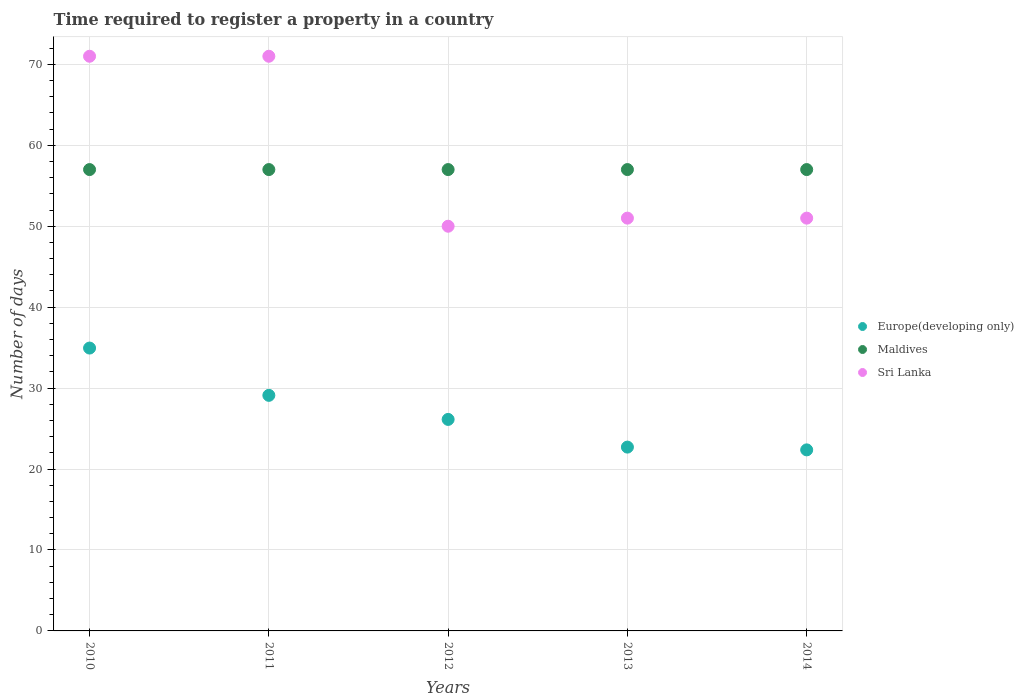What is the number of days required to register a property in Europe(developing only) in 2013?
Offer a very short reply. 22.71. Across all years, what is the maximum number of days required to register a property in Sri Lanka?
Keep it short and to the point. 71. Across all years, what is the minimum number of days required to register a property in Sri Lanka?
Provide a short and direct response. 50. In which year was the number of days required to register a property in Maldives minimum?
Offer a very short reply. 2010. What is the total number of days required to register a property in Sri Lanka in the graph?
Provide a short and direct response. 294. What is the difference between the number of days required to register a property in Maldives in 2010 and that in 2013?
Give a very brief answer. 0. What is the difference between the number of days required to register a property in Europe(developing only) in 2014 and the number of days required to register a property in Sri Lanka in 2012?
Give a very brief answer. -27.63. What is the average number of days required to register a property in Sri Lanka per year?
Ensure brevity in your answer.  58.8. In the year 2011, what is the difference between the number of days required to register a property in Sri Lanka and number of days required to register a property in Europe(developing only)?
Provide a succinct answer. 41.89. What is the ratio of the number of days required to register a property in Maldives in 2010 to that in 2013?
Ensure brevity in your answer.  1. Is the number of days required to register a property in Sri Lanka in 2012 less than that in 2013?
Give a very brief answer. Yes. Is the difference between the number of days required to register a property in Sri Lanka in 2010 and 2011 greater than the difference between the number of days required to register a property in Europe(developing only) in 2010 and 2011?
Provide a short and direct response. No. What is the difference between the highest and the second highest number of days required to register a property in Sri Lanka?
Keep it short and to the point. 0. What is the difference between the highest and the lowest number of days required to register a property in Sri Lanka?
Offer a terse response. 21. In how many years, is the number of days required to register a property in Europe(developing only) greater than the average number of days required to register a property in Europe(developing only) taken over all years?
Give a very brief answer. 2. Is it the case that in every year, the sum of the number of days required to register a property in Europe(developing only) and number of days required to register a property in Maldives  is greater than the number of days required to register a property in Sri Lanka?
Your answer should be compact. Yes. Does the number of days required to register a property in Maldives monotonically increase over the years?
Offer a very short reply. No. Is the number of days required to register a property in Maldives strictly less than the number of days required to register a property in Sri Lanka over the years?
Offer a very short reply. No. How many dotlines are there?
Offer a very short reply. 3. How many years are there in the graph?
Your answer should be very brief. 5. Are the values on the major ticks of Y-axis written in scientific E-notation?
Give a very brief answer. No. Does the graph contain any zero values?
Provide a succinct answer. No. Where does the legend appear in the graph?
Provide a short and direct response. Center right. How many legend labels are there?
Keep it short and to the point. 3. What is the title of the graph?
Offer a terse response. Time required to register a property in a country. What is the label or title of the Y-axis?
Your answer should be very brief. Number of days. What is the Number of days of Europe(developing only) in 2010?
Ensure brevity in your answer.  34.95. What is the Number of days of Maldives in 2010?
Your response must be concise. 57. What is the Number of days of Europe(developing only) in 2011?
Keep it short and to the point. 29.11. What is the Number of days in Sri Lanka in 2011?
Your response must be concise. 71. What is the Number of days in Europe(developing only) in 2012?
Ensure brevity in your answer.  26.13. What is the Number of days in Sri Lanka in 2012?
Make the answer very short. 50. What is the Number of days in Europe(developing only) in 2013?
Provide a short and direct response. 22.71. What is the Number of days of Maldives in 2013?
Offer a terse response. 57. What is the Number of days of Europe(developing only) in 2014?
Make the answer very short. 22.37. Across all years, what is the maximum Number of days of Europe(developing only)?
Keep it short and to the point. 34.95. Across all years, what is the maximum Number of days of Maldives?
Offer a terse response. 57. Across all years, what is the maximum Number of days of Sri Lanka?
Your response must be concise. 71. Across all years, what is the minimum Number of days in Europe(developing only)?
Provide a short and direct response. 22.37. Across all years, what is the minimum Number of days in Maldives?
Your answer should be compact. 57. What is the total Number of days of Europe(developing only) in the graph?
Your answer should be very brief. 135.26. What is the total Number of days in Maldives in the graph?
Offer a very short reply. 285. What is the total Number of days in Sri Lanka in the graph?
Keep it short and to the point. 294. What is the difference between the Number of days of Europe(developing only) in 2010 and that in 2011?
Your response must be concise. 5.84. What is the difference between the Number of days of Maldives in 2010 and that in 2011?
Ensure brevity in your answer.  0. What is the difference between the Number of days of Europe(developing only) in 2010 and that in 2012?
Your answer should be very brief. 8.82. What is the difference between the Number of days in Sri Lanka in 2010 and that in 2012?
Your answer should be very brief. 21. What is the difference between the Number of days in Europe(developing only) in 2010 and that in 2013?
Your response must be concise. 12.24. What is the difference between the Number of days of Maldives in 2010 and that in 2013?
Ensure brevity in your answer.  0. What is the difference between the Number of days in Sri Lanka in 2010 and that in 2013?
Your answer should be compact. 20. What is the difference between the Number of days of Europe(developing only) in 2010 and that in 2014?
Your answer should be compact. 12.58. What is the difference between the Number of days of Europe(developing only) in 2011 and that in 2012?
Ensure brevity in your answer.  2.97. What is the difference between the Number of days in Sri Lanka in 2011 and that in 2012?
Make the answer very short. 21. What is the difference between the Number of days of Europe(developing only) in 2011 and that in 2013?
Offer a very short reply. 6.39. What is the difference between the Number of days in Sri Lanka in 2011 and that in 2013?
Offer a very short reply. 20. What is the difference between the Number of days in Europe(developing only) in 2011 and that in 2014?
Offer a very short reply. 6.74. What is the difference between the Number of days in Europe(developing only) in 2012 and that in 2013?
Your answer should be compact. 3.42. What is the difference between the Number of days in Maldives in 2012 and that in 2013?
Make the answer very short. 0. What is the difference between the Number of days in Europe(developing only) in 2012 and that in 2014?
Offer a terse response. 3.76. What is the difference between the Number of days of Europe(developing only) in 2013 and that in 2014?
Ensure brevity in your answer.  0.34. What is the difference between the Number of days in Maldives in 2013 and that in 2014?
Your answer should be compact. 0. What is the difference between the Number of days of Sri Lanka in 2013 and that in 2014?
Keep it short and to the point. 0. What is the difference between the Number of days of Europe(developing only) in 2010 and the Number of days of Maldives in 2011?
Make the answer very short. -22.05. What is the difference between the Number of days in Europe(developing only) in 2010 and the Number of days in Sri Lanka in 2011?
Your response must be concise. -36.05. What is the difference between the Number of days of Maldives in 2010 and the Number of days of Sri Lanka in 2011?
Your answer should be compact. -14. What is the difference between the Number of days of Europe(developing only) in 2010 and the Number of days of Maldives in 2012?
Offer a very short reply. -22.05. What is the difference between the Number of days in Europe(developing only) in 2010 and the Number of days in Sri Lanka in 2012?
Your answer should be very brief. -15.05. What is the difference between the Number of days in Maldives in 2010 and the Number of days in Sri Lanka in 2012?
Your answer should be compact. 7. What is the difference between the Number of days in Europe(developing only) in 2010 and the Number of days in Maldives in 2013?
Keep it short and to the point. -22.05. What is the difference between the Number of days of Europe(developing only) in 2010 and the Number of days of Sri Lanka in 2013?
Offer a very short reply. -16.05. What is the difference between the Number of days of Europe(developing only) in 2010 and the Number of days of Maldives in 2014?
Offer a terse response. -22.05. What is the difference between the Number of days in Europe(developing only) in 2010 and the Number of days in Sri Lanka in 2014?
Your response must be concise. -16.05. What is the difference between the Number of days in Maldives in 2010 and the Number of days in Sri Lanka in 2014?
Make the answer very short. 6. What is the difference between the Number of days in Europe(developing only) in 2011 and the Number of days in Maldives in 2012?
Your response must be concise. -27.89. What is the difference between the Number of days in Europe(developing only) in 2011 and the Number of days in Sri Lanka in 2012?
Your answer should be compact. -20.89. What is the difference between the Number of days in Maldives in 2011 and the Number of days in Sri Lanka in 2012?
Your answer should be compact. 7. What is the difference between the Number of days of Europe(developing only) in 2011 and the Number of days of Maldives in 2013?
Give a very brief answer. -27.89. What is the difference between the Number of days in Europe(developing only) in 2011 and the Number of days in Sri Lanka in 2013?
Your answer should be compact. -21.89. What is the difference between the Number of days of Maldives in 2011 and the Number of days of Sri Lanka in 2013?
Ensure brevity in your answer.  6. What is the difference between the Number of days of Europe(developing only) in 2011 and the Number of days of Maldives in 2014?
Give a very brief answer. -27.89. What is the difference between the Number of days in Europe(developing only) in 2011 and the Number of days in Sri Lanka in 2014?
Provide a short and direct response. -21.89. What is the difference between the Number of days in Maldives in 2011 and the Number of days in Sri Lanka in 2014?
Your answer should be very brief. 6. What is the difference between the Number of days of Europe(developing only) in 2012 and the Number of days of Maldives in 2013?
Offer a terse response. -30.87. What is the difference between the Number of days of Europe(developing only) in 2012 and the Number of days of Sri Lanka in 2013?
Give a very brief answer. -24.87. What is the difference between the Number of days of Maldives in 2012 and the Number of days of Sri Lanka in 2013?
Offer a terse response. 6. What is the difference between the Number of days in Europe(developing only) in 2012 and the Number of days in Maldives in 2014?
Offer a terse response. -30.87. What is the difference between the Number of days of Europe(developing only) in 2012 and the Number of days of Sri Lanka in 2014?
Provide a succinct answer. -24.87. What is the difference between the Number of days of Europe(developing only) in 2013 and the Number of days of Maldives in 2014?
Provide a short and direct response. -34.29. What is the difference between the Number of days of Europe(developing only) in 2013 and the Number of days of Sri Lanka in 2014?
Your answer should be very brief. -28.29. What is the difference between the Number of days in Maldives in 2013 and the Number of days in Sri Lanka in 2014?
Offer a very short reply. 6. What is the average Number of days of Europe(developing only) per year?
Provide a succinct answer. 27.05. What is the average Number of days of Sri Lanka per year?
Provide a succinct answer. 58.8. In the year 2010, what is the difference between the Number of days of Europe(developing only) and Number of days of Maldives?
Your answer should be compact. -22.05. In the year 2010, what is the difference between the Number of days of Europe(developing only) and Number of days of Sri Lanka?
Keep it short and to the point. -36.05. In the year 2010, what is the difference between the Number of days of Maldives and Number of days of Sri Lanka?
Your response must be concise. -14. In the year 2011, what is the difference between the Number of days in Europe(developing only) and Number of days in Maldives?
Provide a succinct answer. -27.89. In the year 2011, what is the difference between the Number of days of Europe(developing only) and Number of days of Sri Lanka?
Keep it short and to the point. -41.89. In the year 2012, what is the difference between the Number of days of Europe(developing only) and Number of days of Maldives?
Ensure brevity in your answer.  -30.87. In the year 2012, what is the difference between the Number of days in Europe(developing only) and Number of days in Sri Lanka?
Provide a short and direct response. -23.87. In the year 2013, what is the difference between the Number of days of Europe(developing only) and Number of days of Maldives?
Provide a succinct answer. -34.29. In the year 2013, what is the difference between the Number of days of Europe(developing only) and Number of days of Sri Lanka?
Provide a succinct answer. -28.29. In the year 2013, what is the difference between the Number of days in Maldives and Number of days in Sri Lanka?
Your response must be concise. 6. In the year 2014, what is the difference between the Number of days in Europe(developing only) and Number of days in Maldives?
Provide a succinct answer. -34.63. In the year 2014, what is the difference between the Number of days of Europe(developing only) and Number of days of Sri Lanka?
Offer a very short reply. -28.63. In the year 2014, what is the difference between the Number of days of Maldives and Number of days of Sri Lanka?
Offer a terse response. 6. What is the ratio of the Number of days in Europe(developing only) in 2010 to that in 2011?
Offer a terse response. 1.2. What is the ratio of the Number of days in Maldives in 2010 to that in 2011?
Offer a very short reply. 1. What is the ratio of the Number of days of Europe(developing only) in 2010 to that in 2012?
Ensure brevity in your answer.  1.34. What is the ratio of the Number of days of Sri Lanka in 2010 to that in 2012?
Give a very brief answer. 1.42. What is the ratio of the Number of days of Europe(developing only) in 2010 to that in 2013?
Keep it short and to the point. 1.54. What is the ratio of the Number of days in Sri Lanka in 2010 to that in 2013?
Make the answer very short. 1.39. What is the ratio of the Number of days in Europe(developing only) in 2010 to that in 2014?
Your answer should be compact. 1.56. What is the ratio of the Number of days of Sri Lanka in 2010 to that in 2014?
Keep it short and to the point. 1.39. What is the ratio of the Number of days in Europe(developing only) in 2011 to that in 2012?
Offer a very short reply. 1.11. What is the ratio of the Number of days in Sri Lanka in 2011 to that in 2012?
Your answer should be very brief. 1.42. What is the ratio of the Number of days of Europe(developing only) in 2011 to that in 2013?
Ensure brevity in your answer.  1.28. What is the ratio of the Number of days in Maldives in 2011 to that in 2013?
Offer a very short reply. 1. What is the ratio of the Number of days in Sri Lanka in 2011 to that in 2013?
Provide a short and direct response. 1.39. What is the ratio of the Number of days of Europe(developing only) in 2011 to that in 2014?
Keep it short and to the point. 1.3. What is the ratio of the Number of days in Sri Lanka in 2011 to that in 2014?
Your response must be concise. 1.39. What is the ratio of the Number of days of Europe(developing only) in 2012 to that in 2013?
Offer a very short reply. 1.15. What is the ratio of the Number of days in Maldives in 2012 to that in 2013?
Provide a short and direct response. 1. What is the ratio of the Number of days in Sri Lanka in 2012 to that in 2013?
Ensure brevity in your answer.  0.98. What is the ratio of the Number of days of Europe(developing only) in 2012 to that in 2014?
Your answer should be compact. 1.17. What is the ratio of the Number of days in Maldives in 2012 to that in 2014?
Your answer should be very brief. 1. What is the ratio of the Number of days in Sri Lanka in 2012 to that in 2014?
Provide a short and direct response. 0.98. What is the ratio of the Number of days of Europe(developing only) in 2013 to that in 2014?
Ensure brevity in your answer.  1.02. What is the ratio of the Number of days of Sri Lanka in 2013 to that in 2014?
Your answer should be compact. 1. What is the difference between the highest and the second highest Number of days of Europe(developing only)?
Offer a terse response. 5.84. What is the difference between the highest and the second highest Number of days in Maldives?
Your response must be concise. 0. What is the difference between the highest and the lowest Number of days in Europe(developing only)?
Provide a short and direct response. 12.58. What is the difference between the highest and the lowest Number of days in Maldives?
Provide a succinct answer. 0. 